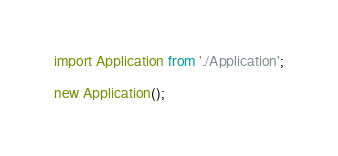Convert code to text. <code><loc_0><loc_0><loc_500><loc_500><_JavaScript_>import Application from './Application';

new Application();</code> 